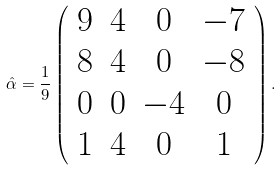Convert formula to latex. <formula><loc_0><loc_0><loc_500><loc_500>\hat { \alpha } = \frac { 1 } { 9 } \left ( \begin{array} { c c c c } 9 & 4 & 0 & - 7 \\ 8 & 4 & 0 & - 8 \\ 0 & 0 & - 4 & 0 \\ 1 & 4 & 0 & 1 \end{array} \right ) .</formula> 